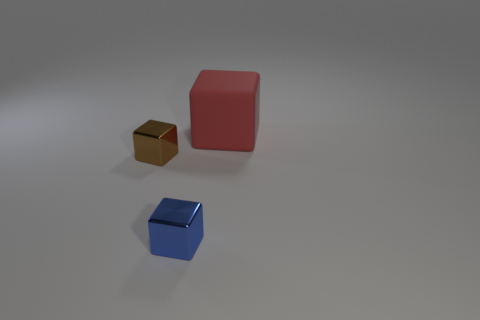There is a cube that is behind the blue metal block and on the left side of the big matte block; what material is it?
Provide a short and direct response. Metal. The other small thing that is the same shape as the tiny brown object is what color?
Your answer should be very brief. Blue. There is a small block that is in front of the brown metal block; are there any large rubber objects in front of it?
Your response must be concise. No. What size is the brown block?
Provide a succinct answer. Small. There is a object that is in front of the big red object and to the right of the brown shiny object; what shape is it?
Keep it short and to the point. Cube. How many brown objects are either small metallic blocks or large rubber objects?
Give a very brief answer. 1. Does the metallic thing behind the small blue cube have the same size as the object right of the blue block?
Your answer should be very brief. No. What number of things are either metallic things or blue shiny things?
Give a very brief answer. 2. Is there another small blue matte thing of the same shape as the small blue thing?
Your answer should be very brief. No. Is the number of small blue objects less than the number of small cyan cylinders?
Keep it short and to the point. No. 